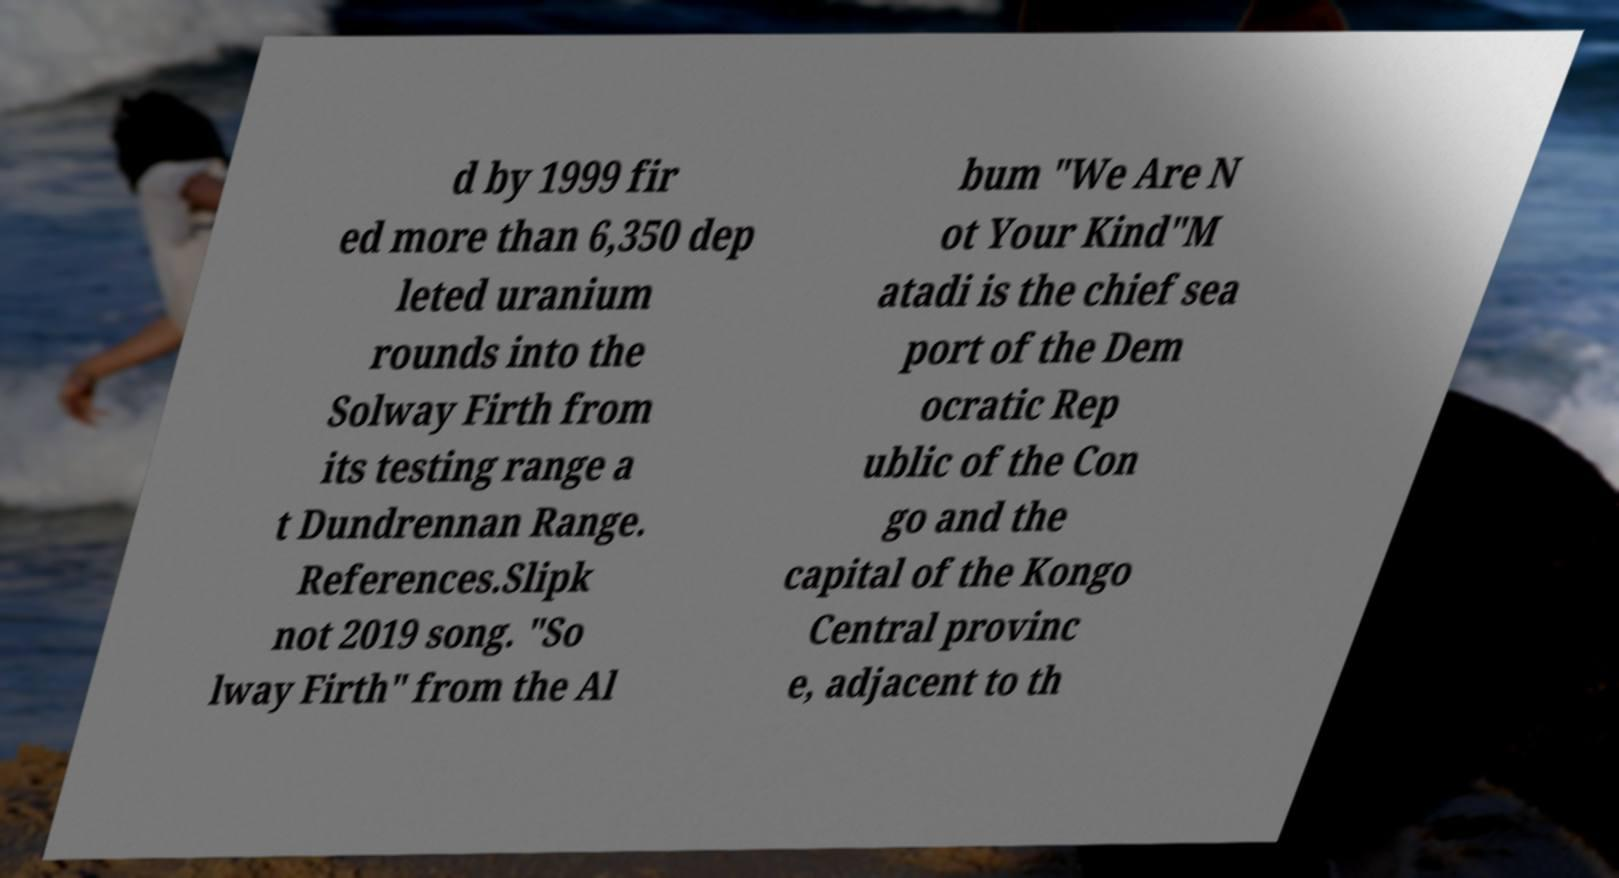Can you accurately transcribe the text from the provided image for me? d by 1999 fir ed more than 6,350 dep leted uranium rounds into the Solway Firth from its testing range a t Dundrennan Range. References.Slipk not 2019 song. "So lway Firth" from the Al bum "We Are N ot Your Kind"M atadi is the chief sea port of the Dem ocratic Rep ublic of the Con go and the capital of the Kongo Central provinc e, adjacent to th 